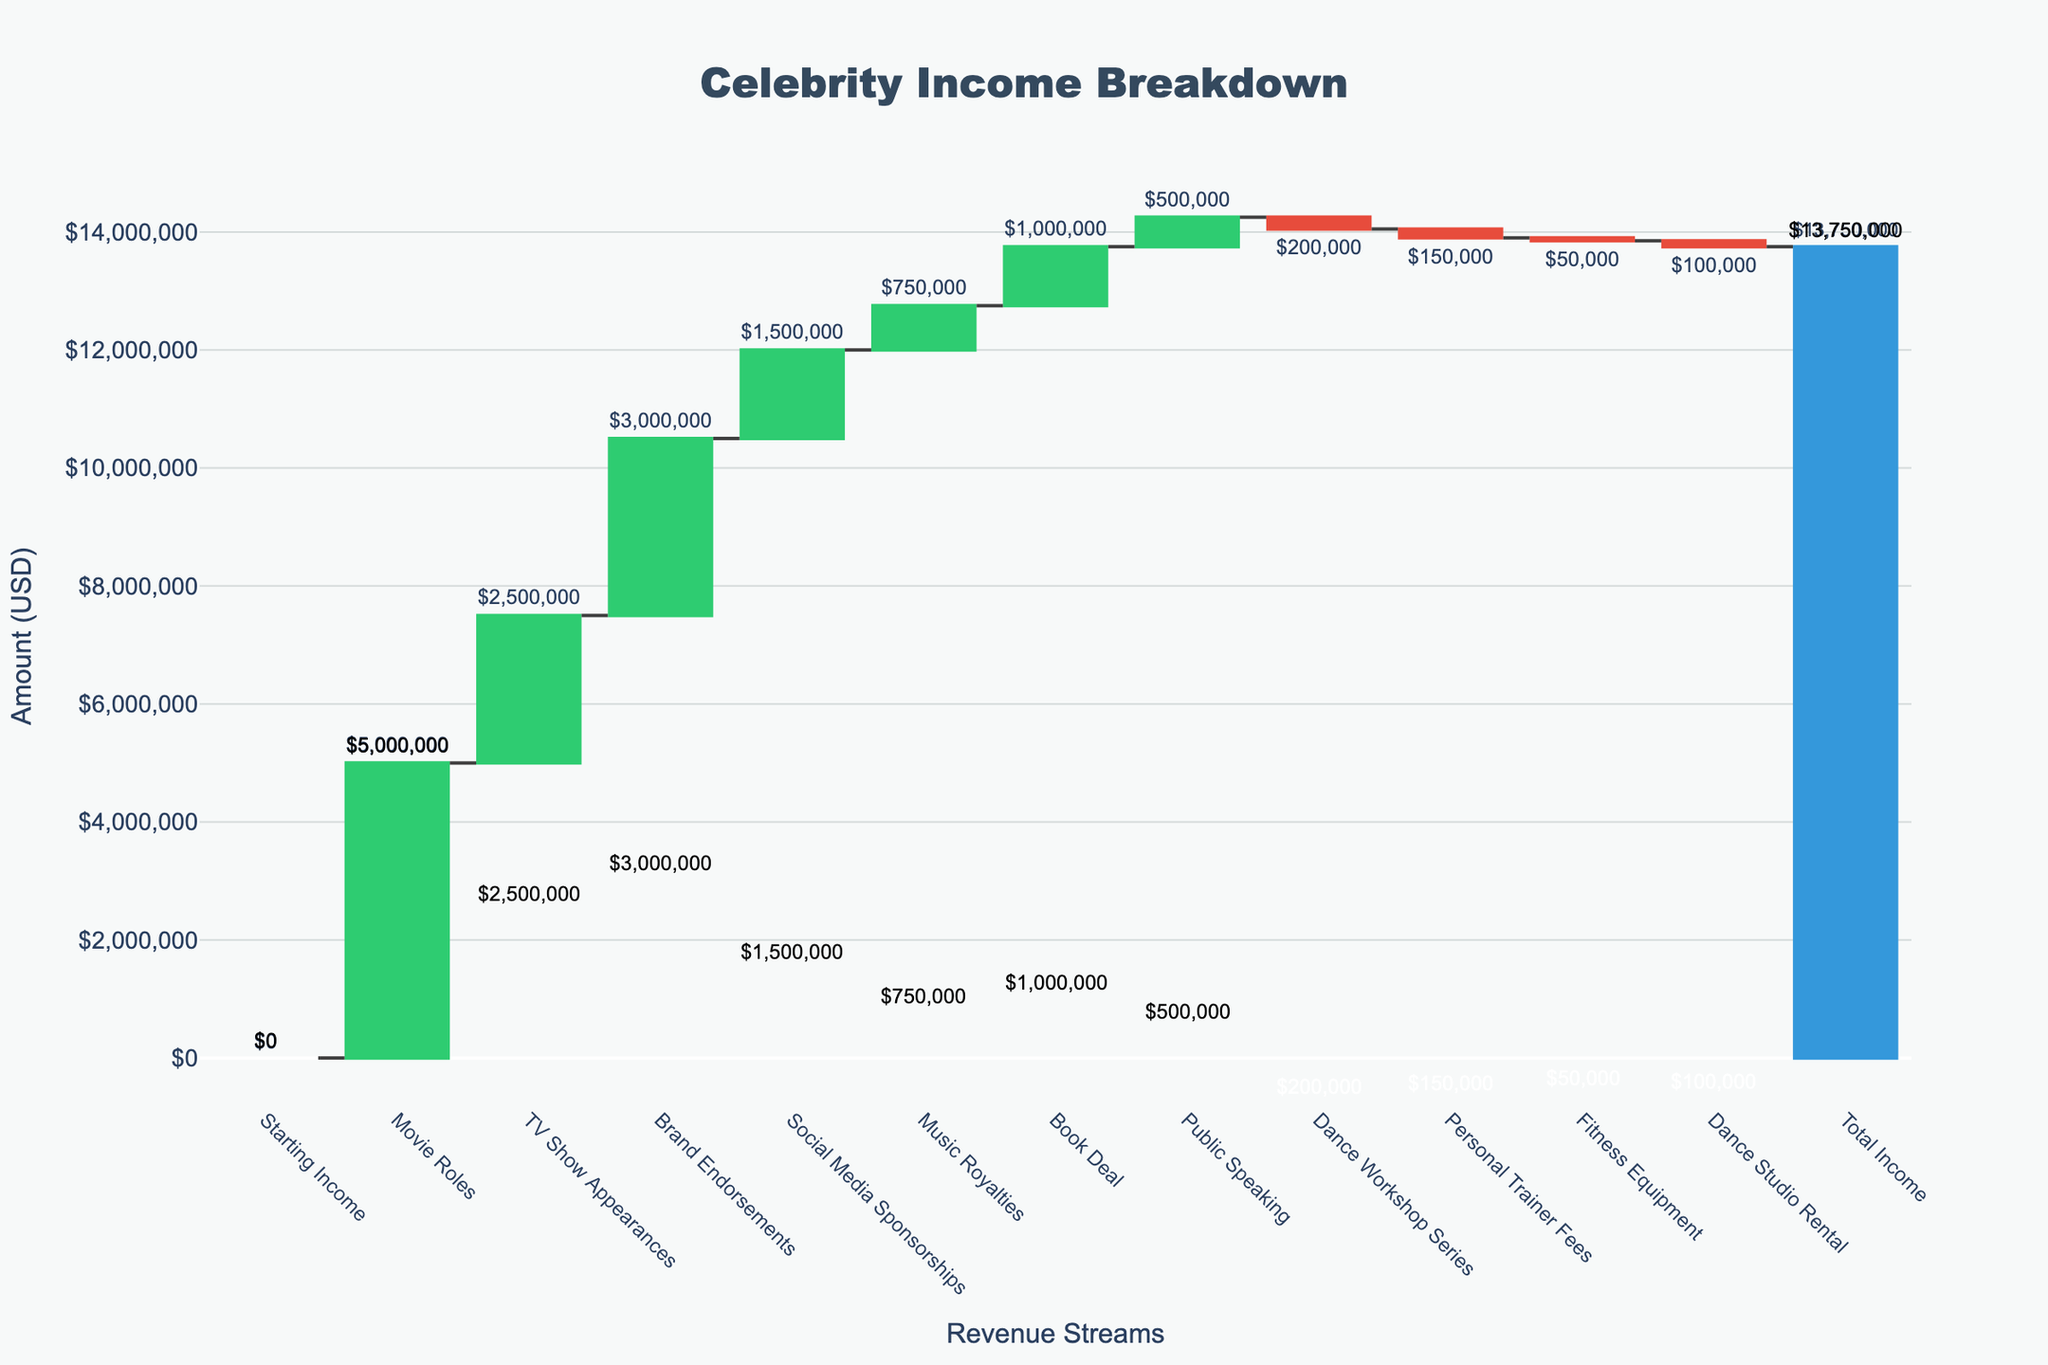What's the title of the chart? The title is usually found at the top center of the chart and provides the main description of the content. In this case, the title is "Celebrity Income Breakdown".
Answer: Celebrity Income Breakdown How much income did the celebrity earn from TV Show Appearances? Look for the bar labeled "TV Show Appearances" and read the associated value. Here, it shows a value of $2,500,000.
Answer: $2,500,000 Which revenue stream contributed the most to the total income? Compare the heights of the positive bars. The highest bar represents "Movie Roles" with a value of $5,000,000.
Answer: Movie Roles What is the net impact of expenses on the total income? Combine the values of all negative bars: Dance Workshop Series (-$200,000), Personal Trainer Fees (-$150,000), Fitness Equipment (-$50,000), and Dance Studio Rental (-$100,000). The total impact is -$500,000.
Answer: $500,000 What is the total income after all revenue and expenses are accounted for? Look at the final bar labeled "Total Income" and note its value. The chart shows this value as $13,750,000.
Answer: $13,750,000 How much more did the celebrity make from Music Royalties compared to Public Speaking? Identify the values for "Music Royalties" ($750,000) and "Public Speaking" ($500,000). Calculate the difference: $750,000 - $500,000 = $250,000.
Answer: $250,000 What is the impact of Brand Endorsements on the total income? Find the bar labeled "Brand Endorsements" and note its value, which is $3,000,000. This reflects the positive impact of increasing the total income by this amount.
Answer: $3,000,000 How does the value from Social Media Sponsorships compare to the value from the Book Deal? Locate the values for "Social Media Sponsorships" ($1,500,000) and "Book Deal" ($1,000,000). The value from Social Media Sponsorships is $500,000 more than the value from the Book Deal.
Answer: $500,000 more What categories represent expenses, and what is their total contribution? Identify and sum the values of the negative bars: Dance Workshop Series (-$200,000), Personal Trainer Fees (-$150,000), Fitness Equipment (-$50,000), Dance Studio Rental (-$100,000). Their total is -$500,000.
Answer: Dance Workshop, Personal Trainer Fees, Fitness Equipment, Dance Studio Rental, $500,000 If the celebrity decides to cut $50,000 from Personal Trainer Fees, what would be the new Total Income? The current Total Income is $13,750,000. Reducing Personal Trainer Fees by $50,000 would change it to -$100,000, reducing the expense by $50,000. Therefore, the new Total Income would increase by $50,000 to $13,800,000.
Answer: $13,800,000 